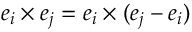<formula> <loc_0><loc_0><loc_500><loc_500>e _ { i } \times e _ { j } = e _ { i } \times ( e _ { j } - e _ { i } )</formula> 